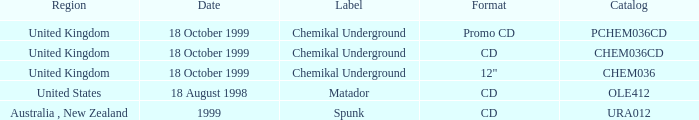What date is associated with the Spunk label? 1999.0. 